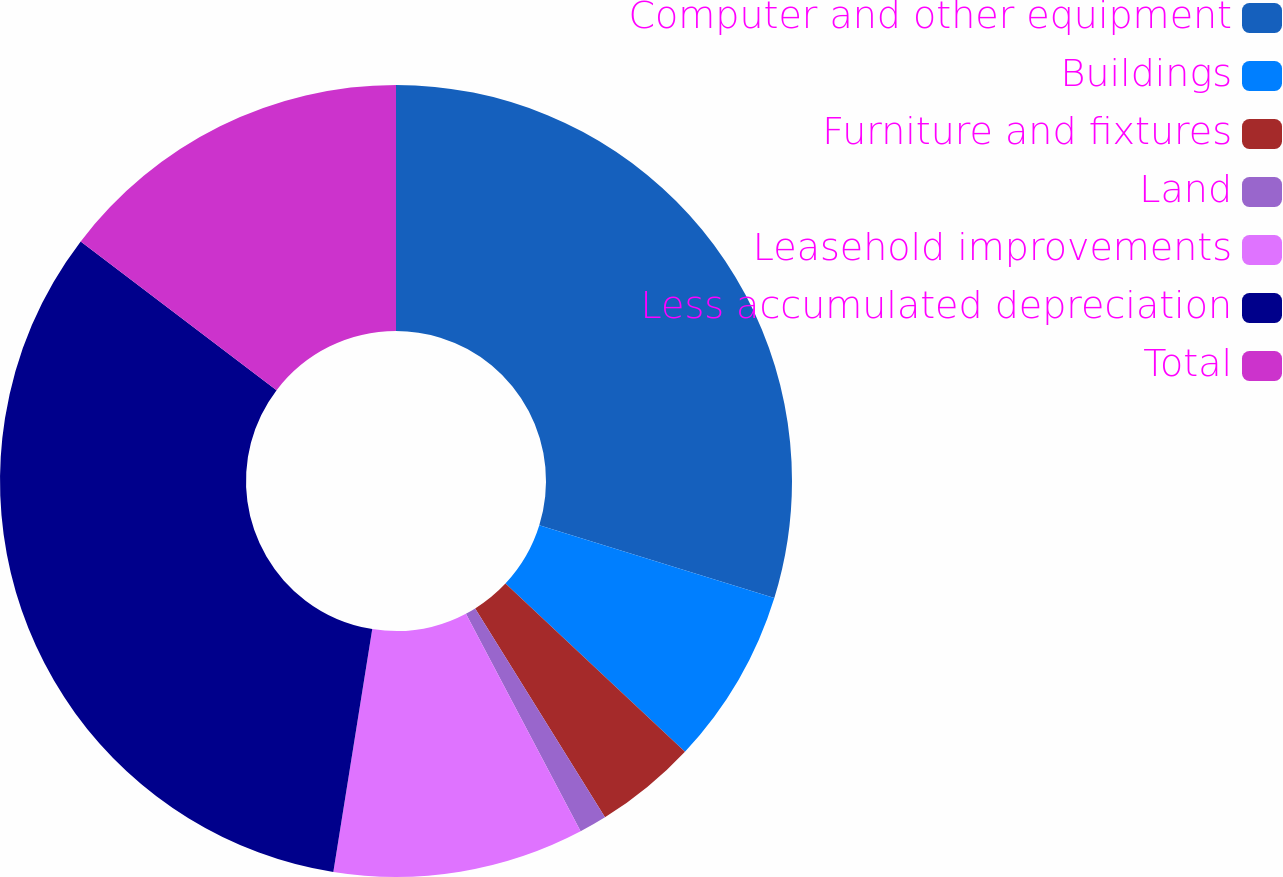Convert chart to OTSL. <chart><loc_0><loc_0><loc_500><loc_500><pie_chart><fcel>Computer and other equipment<fcel>Buildings<fcel>Furniture and fixtures<fcel>Land<fcel>Leasehold improvements<fcel>Less accumulated depreciation<fcel>Total<nl><fcel>29.78%<fcel>7.21%<fcel>4.17%<fcel>1.13%<fcel>10.25%<fcel>32.82%<fcel>14.66%<nl></chart> 